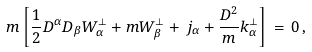Convert formula to latex. <formula><loc_0><loc_0><loc_500><loc_500>m \left [ \frac { 1 } { 2 } D ^ { \alpha } D _ { \beta } W _ { \alpha } ^ { \perp } + m W _ { \beta } ^ { \perp } + \, j _ { \alpha } + \frac { D ^ { 2 } } { m } k _ { \alpha } ^ { \perp } \right ] \, = \, 0 \, ,</formula> 